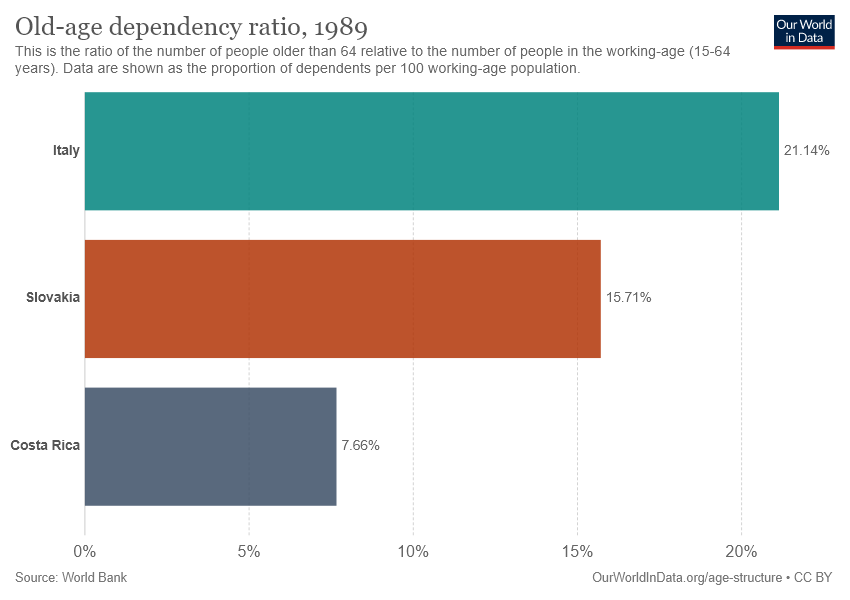Give some essential details in this illustration. The smallest decimal value of percentage is 0.0766... The value of Slovakia and Costa Rica is [15.71, 7.66], according to the provided data. 